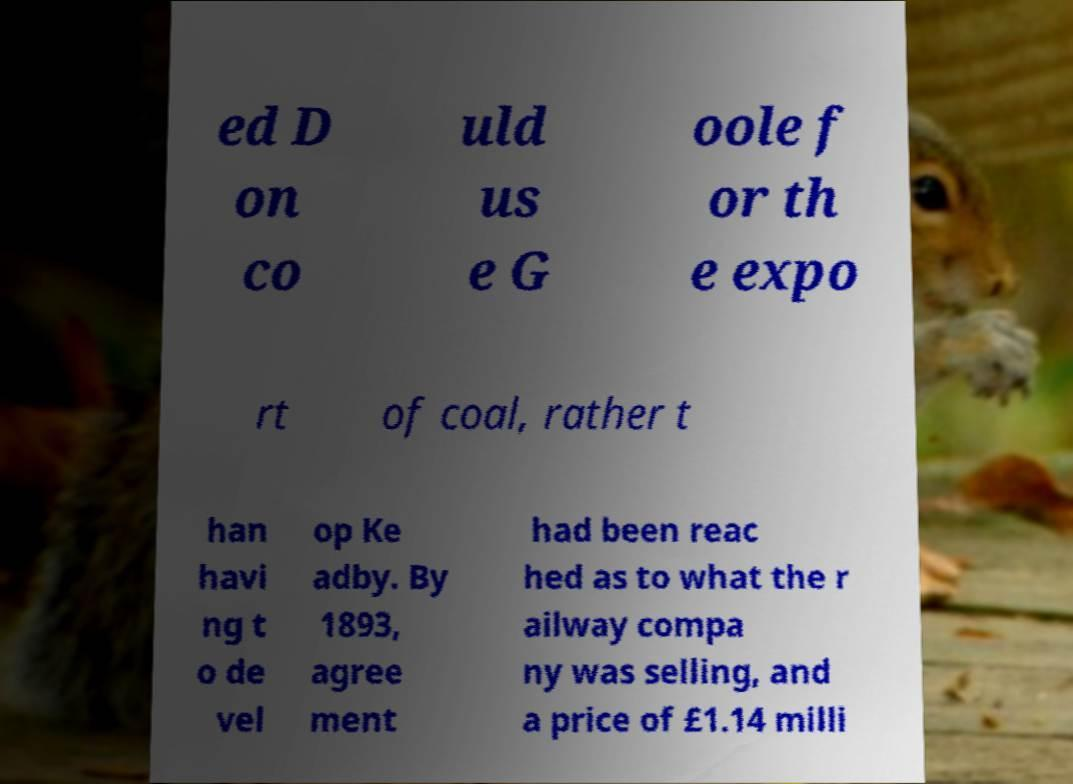Could you extract and type out the text from this image? ed D on co uld us e G oole f or th e expo rt of coal, rather t han havi ng t o de vel op Ke adby. By 1893, agree ment had been reac hed as to what the r ailway compa ny was selling, and a price of £1.14 milli 